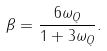Convert formula to latex. <formula><loc_0><loc_0><loc_500><loc_500>\beta = \frac { 6 \omega _ { Q } } { 1 + 3 \omega _ { Q } } .</formula> 